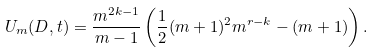Convert formula to latex. <formula><loc_0><loc_0><loc_500><loc_500>U _ { m } ( D , t ) & = \frac { m ^ { 2 k - 1 } } { m - 1 } \left ( \frac { 1 } { 2 } ( m + 1 ) ^ { 2 } m ^ { r - k } - ( m + 1 ) \right ) .</formula> 